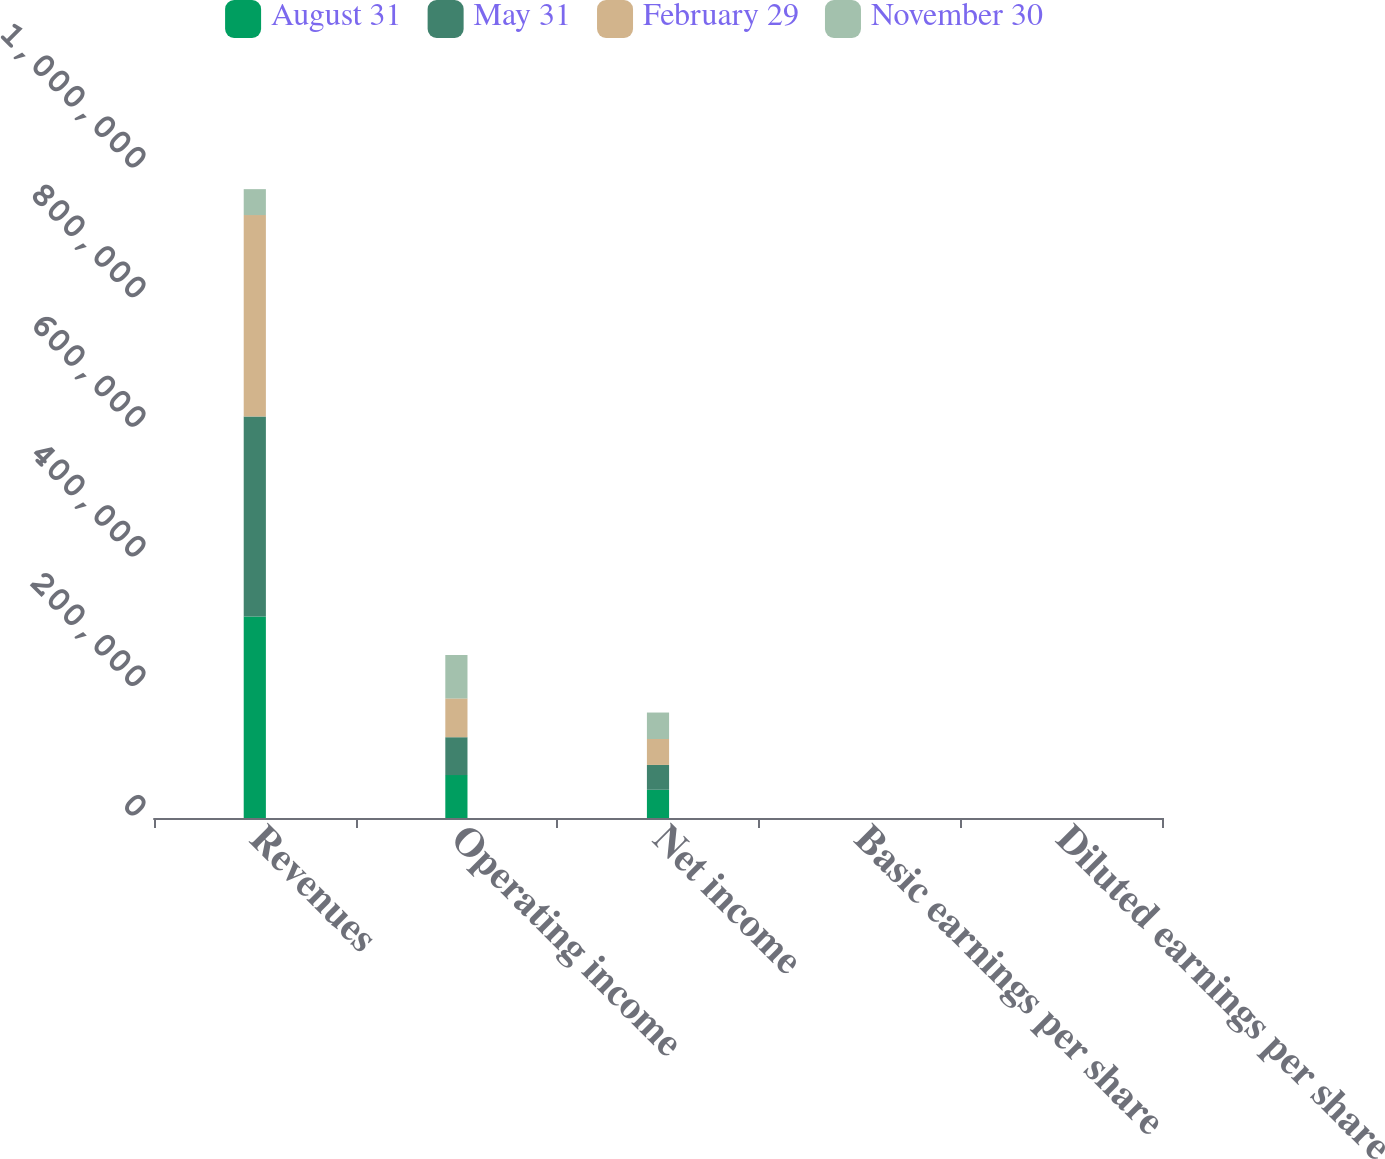Convert chart to OTSL. <chart><loc_0><loc_0><loc_500><loc_500><stacked_bar_chart><ecel><fcel>Revenues<fcel>Operating income<fcel>Net income<fcel>Basic earnings per share<fcel>Diluted earnings per share<nl><fcel>August 31<fcel>310980<fcel>66232<fcel>43575<fcel>0.54<fcel>0.53<nl><fcel>May 31<fcel>308776<fcel>58431<fcel>38313<fcel>0.48<fcel>0.48<nl><fcel>February 29<fcel>310641<fcel>59911<fcel>40055<fcel>0.51<fcel>0.5<nl><fcel>November 30<fcel>40055<fcel>66785<fcel>40811<fcel>0.51<fcel>0.5<nl></chart> 